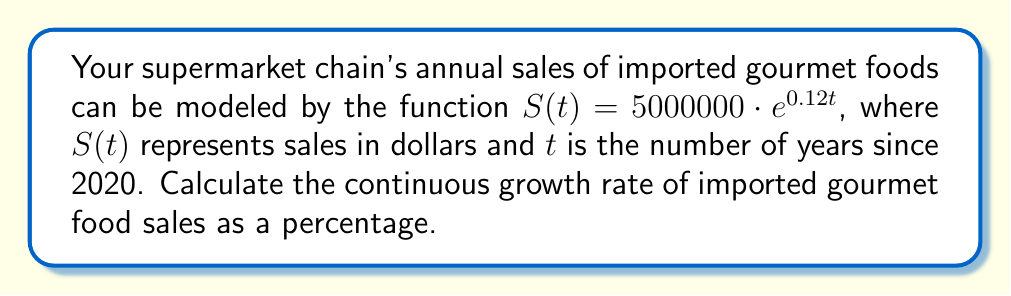Can you solve this math problem? To solve this problem, we'll follow these steps:

1) The general form of an exponential growth function is:

   $S(t) = S_0 \cdot e^{rt}$

   where $S_0$ is the initial value, $r$ is the continuous growth rate, and $t$ is time.

2) In our given function $S(t) = 5000000 \cdot e^{0.12t}$, we can identify:

   $S_0 = 5000000$
   $r = 0.12$

3) The continuous growth rate $r$ is already given in the exponent: 0.12

4) To convert this to a percentage, we multiply by 100:

   Growth rate = $0.12 \times 100 = 12\%$

5) Therefore, the continuous growth rate of imported gourmet food sales is 12% per year.

Note: We didn't need to use logarithms in this case because the growth rate was directly visible in the exponential function. Logarithms would be necessary if we needed to solve for the growth rate given two points on the curve.
Answer: 12% 